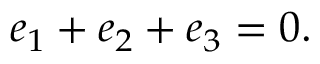Convert formula to latex. <formula><loc_0><loc_0><loc_500><loc_500>e _ { 1 } + e _ { 2 } + e _ { 3 } = 0 .</formula> 